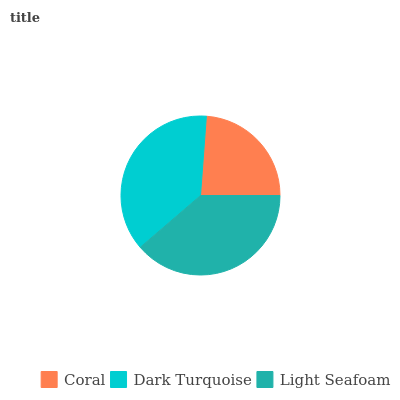Is Coral the minimum?
Answer yes or no. Yes. Is Light Seafoam the maximum?
Answer yes or no. Yes. Is Dark Turquoise the minimum?
Answer yes or no. No. Is Dark Turquoise the maximum?
Answer yes or no. No. Is Dark Turquoise greater than Coral?
Answer yes or no. Yes. Is Coral less than Dark Turquoise?
Answer yes or no. Yes. Is Coral greater than Dark Turquoise?
Answer yes or no. No. Is Dark Turquoise less than Coral?
Answer yes or no. No. Is Dark Turquoise the high median?
Answer yes or no. Yes. Is Dark Turquoise the low median?
Answer yes or no. Yes. Is Light Seafoam the high median?
Answer yes or no. No. Is Light Seafoam the low median?
Answer yes or no. No. 